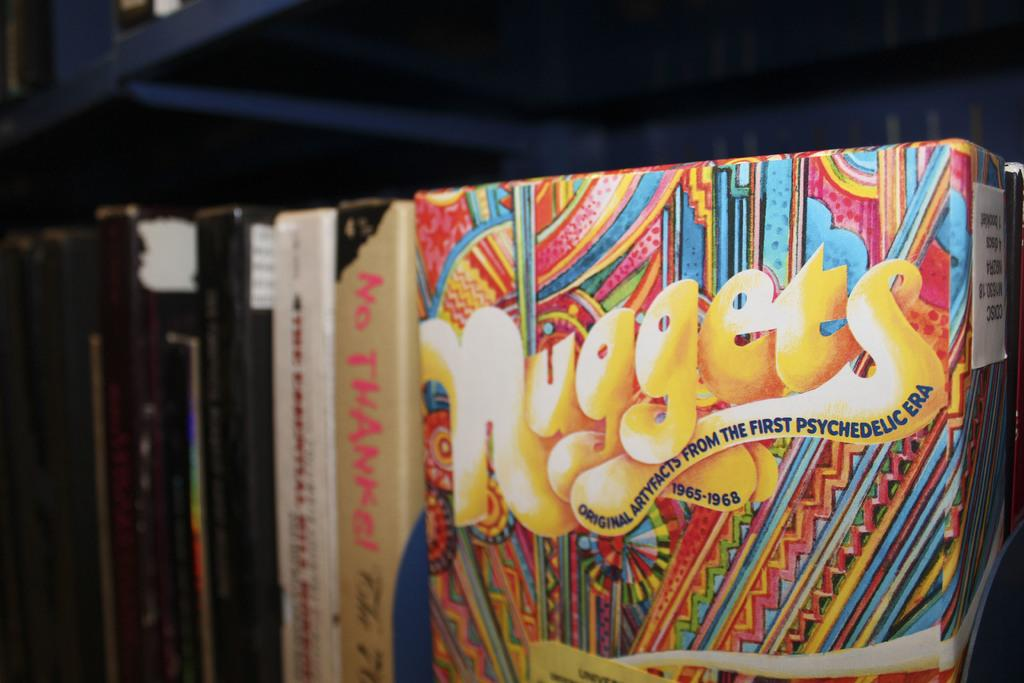<image>
Share a concise interpretation of the image provided. The books here are from a series called Nuggets 